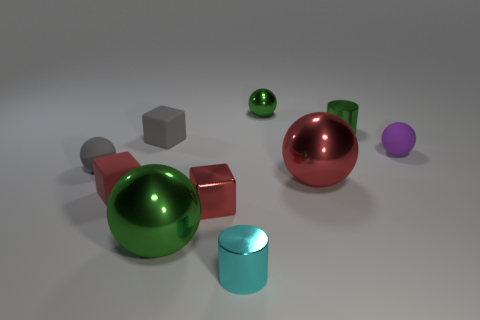Subtract all purple spheres. How many spheres are left? 4 Subtract all small green balls. How many balls are left? 4 Subtract all blue spheres. Subtract all red cylinders. How many spheres are left? 5 Subtract all cylinders. How many objects are left? 8 Subtract 0 cyan balls. How many objects are left? 10 Subtract all small green rubber cylinders. Subtract all shiny spheres. How many objects are left? 7 Add 1 large red things. How many large red things are left? 2 Add 5 large green metal spheres. How many large green metal spheres exist? 6 